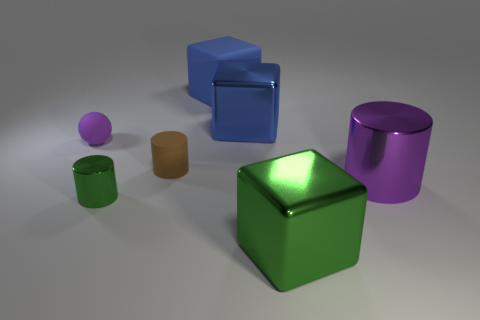Are there any big yellow rubber objects?
Keep it short and to the point. No. Are there more spheres behind the purple shiny cylinder than large green shiny cubes behind the tiny shiny thing?
Give a very brief answer. Yes. There is a object that is both on the left side of the big blue shiny block and to the right of the small brown rubber cylinder; what material is it?
Your answer should be compact. Rubber. Is the shape of the brown thing the same as the large purple metallic thing?
Your answer should be very brief. Yes. Are there any other things that have the same size as the green metal cylinder?
Keep it short and to the point. Yes. There is a small purple object; what number of matte cubes are behind it?
Offer a very short reply. 1. Do the rubber thing on the right side of the brown cylinder and the big green metallic thing have the same size?
Ensure brevity in your answer.  Yes. There is another metal thing that is the same shape as the large green thing; what is its color?
Your answer should be compact. Blue. Is there anything else that has the same shape as the brown rubber thing?
Keep it short and to the point. Yes. What shape is the purple thing that is on the left side of the small metal thing?
Provide a short and direct response. Sphere. 